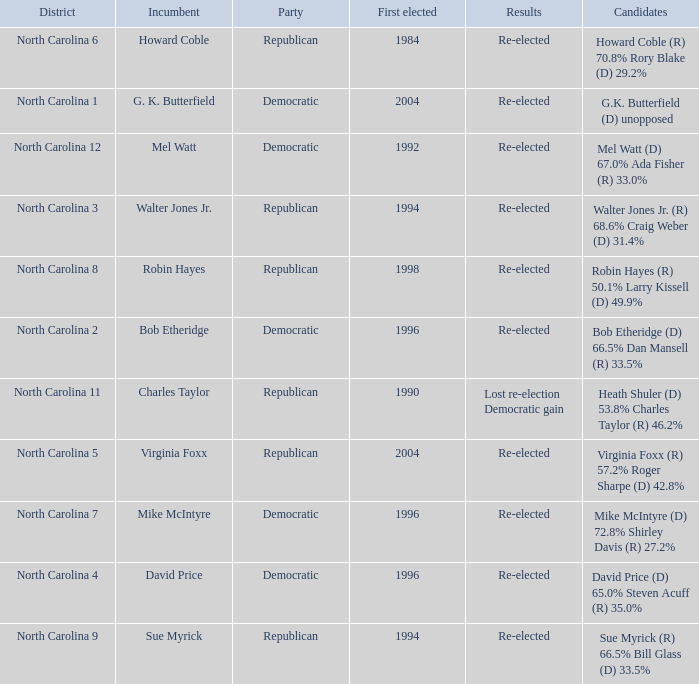Which party was elected first in 1998? Republican. 